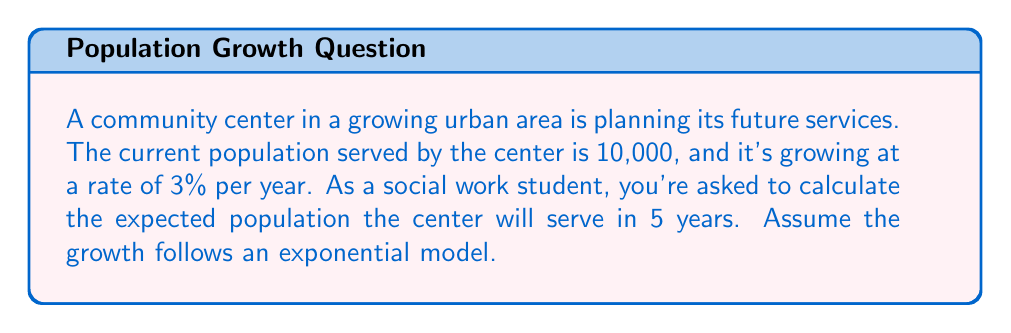Show me your answer to this math problem. To solve this problem, we'll use the exponential growth formula:

$$A = P(1 + r)^t$$

Where:
$A$ = Final amount
$P$ = Initial principal balance
$r$ = Annual growth rate (as a decimal)
$t$ = Time in years

Given:
$P = 10,000$ (initial population)
$r = 0.03$ (3% annual growth rate)
$t = 5$ years

Let's plug these values into the formula:

$$A = 10,000(1 + 0.03)^5$$

Now, let's solve step-by-step:

1) First, calculate $(1 + 0.03)^5$:
   $$(1.03)^5 = 1.159274$$

2) Multiply this result by the initial population:
   $$10,000 \times 1.159274 = 11,592.74$$

3) Round to the nearest whole number, as we're dealing with people:
   $$11,592.74 \approx 11,593$$

Therefore, in 5 years, the community center is expected to serve a population of 11,593 people.
Answer: 11,593 people 